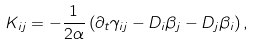Convert formula to latex. <formula><loc_0><loc_0><loc_500><loc_500>K _ { i j } = - \frac { 1 } { 2 \alpha } \left ( \partial _ { t } \gamma _ { i j } - D _ { i } \beta _ { j } - D _ { j } \beta _ { i } \right ) ,</formula> 